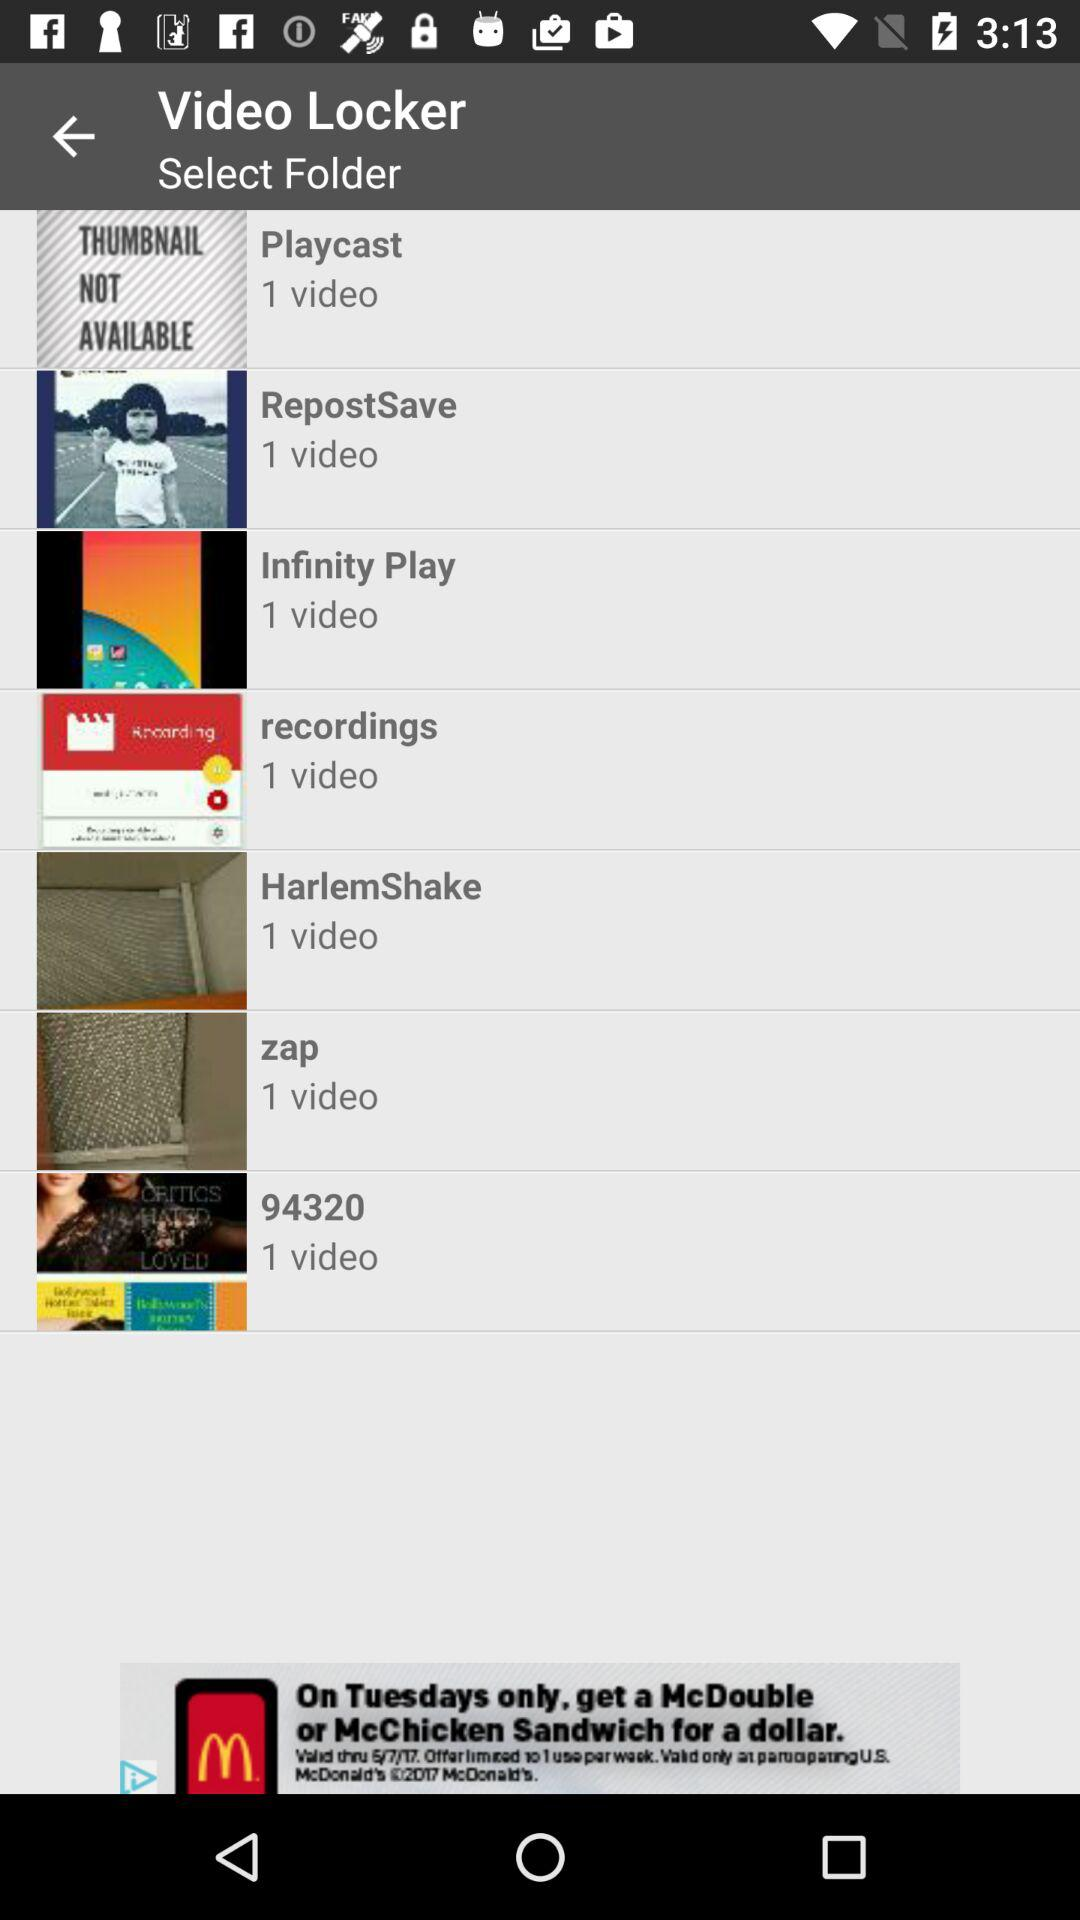What is the name of the application? The name of the application is "Video Locker". 